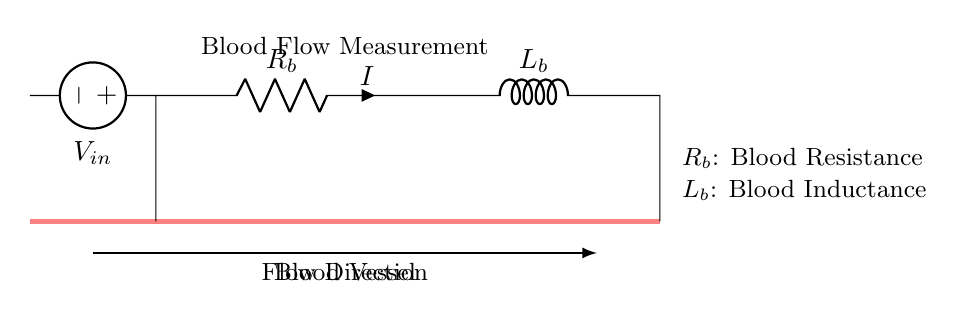what is the voltage source in the circuit? The voltage source shown in the circuit is marked as V in. It is positioned at the leftmost part of the circuit diagram, supplying electrical power to the circuit.
Answer: V in what does R_b represent in this circuit? R_b represents blood resistance, which is indicated directly by the label on the resistor in the diagram. It shows how the blood flow encounters resistance in the blood vessel.
Answer: blood resistance what component is marked L_b? L_b is marked as the inductor in the circuit, which is indicated as how blood flow may have an inductive effect. It shows that there’s a reactive component to the blood flow due to changes over time.
Answer: blood inductance how is the current represented in the circuit? The current is represented by the symbol I next to the resistor R_b in the diagram. This indicates the direction and magnitude of the current flowing through the circuit elements.
Answer: I what implication does the inductor have in the blood flow measurement? The inductor in the circuit, labeled as L_b, suggests that there may be a time-varying component to the blood flow, capturing the dynamics of blood motion and its changes, influencing the overall response of the circuit.
Answer: dynamic response what is the flow direction of blood indicated in the diagram? The flow direction is indicated by the arrow below the blood vessel path, showing movement from left to right in the circuit representation. This indicates the direction in which the blood is flowing through the vessel.
Answer: left to right 